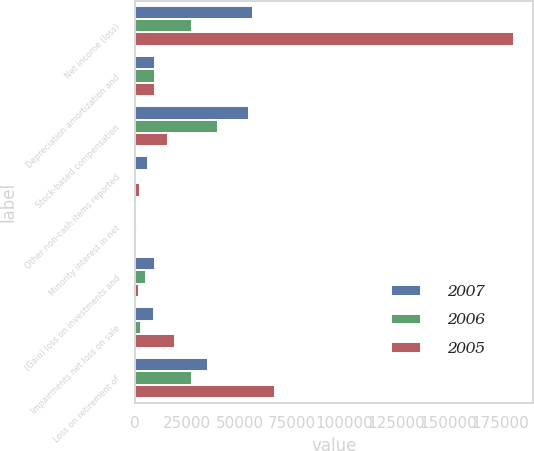Convert chart to OTSL. <chart><loc_0><loc_0><loc_500><loc_500><stacked_bar_chart><ecel><fcel>Net income (loss)<fcel>Depreciation amortization and<fcel>Stock-based compensation<fcel>Other non-cash items reported<fcel>Minority interest in net<fcel>(Gain) loss on investments and<fcel>Impairments net loss on sale<fcel>Loss on retirement of<nl><fcel>2007<fcel>56316<fcel>9470<fcel>54603<fcel>6192<fcel>338<fcel>9470<fcel>9214<fcel>34826<nl><fcel>2006<fcel>27484<fcel>9470<fcel>39502<fcel>444<fcel>784<fcel>5453<fcel>2958<fcel>27223<nl><fcel>2005<fcel>181359<fcel>9470<fcel>15930<fcel>2145<fcel>575<fcel>2078<fcel>19096<fcel>67110<nl></chart> 